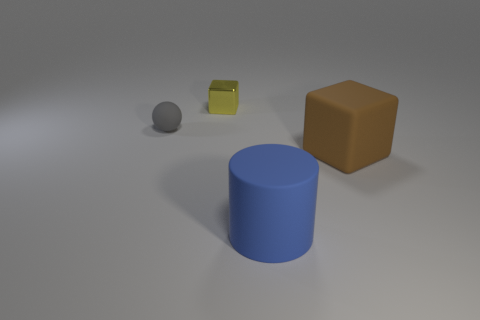How many objects are behind the large blue cylinder and to the right of the gray matte object?
Ensure brevity in your answer.  2. What shape is the matte object behind the brown block?
Give a very brief answer. Sphere. What number of large blue things are the same material as the big cube?
Provide a succinct answer. 1. Is the shape of the brown object the same as the small thing that is behind the tiny gray matte object?
Give a very brief answer. Yes. Are there any large brown cubes that are to the left of the block that is in front of the block to the left of the large rubber cylinder?
Your answer should be very brief. No. How big is the cube right of the cylinder?
Your answer should be compact. Large. There is a brown block that is the same size as the blue rubber cylinder; what material is it?
Provide a short and direct response. Rubber. Is the small metallic object the same shape as the big blue rubber thing?
Offer a terse response. No. How many objects are either metallic objects or objects that are on the right side of the tiny yellow block?
Provide a short and direct response. 3. There is a rubber object that is to the left of the yellow metal block; is its size the same as the big brown rubber object?
Your answer should be compact. No. 